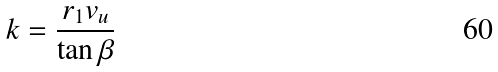<formula> <loc_0><loc_0><loc_500><loc_500>k = \frac { r _ { 1 } v _ { u } } { \tan \beta }</formula> 